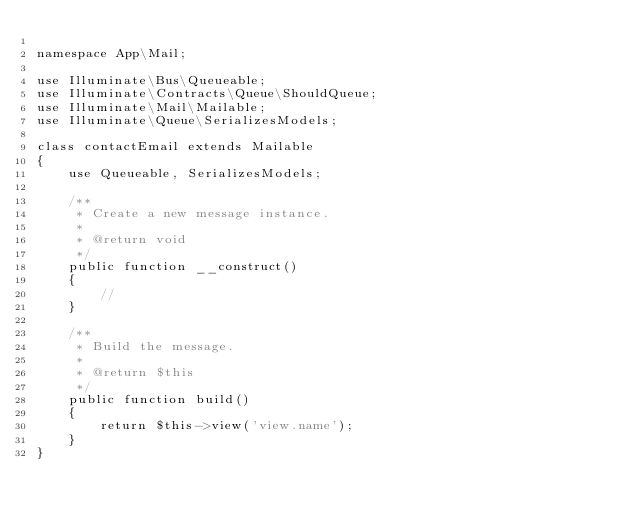<code> <loc_0><loc_0><loc_500><loc_500><_PHP_>
namespace App\Mail;

use Illuminate\Bus\Queueable;
use Illuminate\Contracts\Queue\ShouldQueue;
use Illuminate\Mail\Mailable;
use Illuminate\Queue\SerializesModels;

class contactEmail extends Mailable
{
    use Queueable, SerializesModels;

    /**
     * Create a new message instance.
     *
     * @return void
     */
    public function __construct()
    {
        //
    }

    /**
     * Build the message.
     *
     * @return $this
     */
    public function build()
    {
        return $this->view('view.name');
    }
}
</code> 